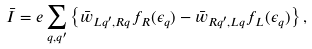<formula> <loc_0><loc_0><loc_500><loc_500>\bar { I } = e \sum _ { q , q ^ { \prime } } \left \{ \bar { w } _ { L q ^ { \prime } , R q } f _ { R } ( \epsilon _ { q } ) - \bar { w } _ { R q ^ { \prime } , L q } f _ { L } ( \epsilon _ { q } ) \right \} ,</formula> 